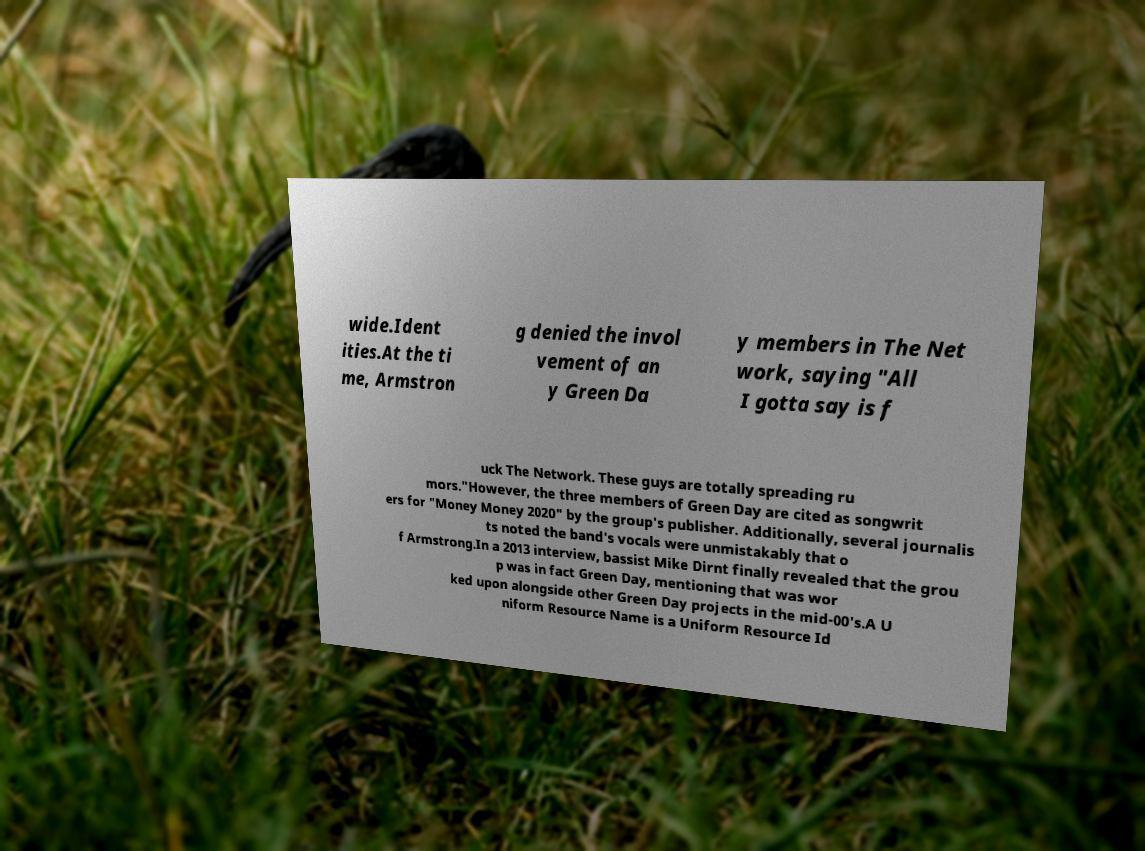Can you read and provide the text displayed in the image?This photo seems to have some interesting text. Can you extract and type it out for me? wide.Ident ities.At the ti me, Armstron g denied the invol vement of an y Green Da y members in The Net work, saying "All I gotta say is f uck The Network. These guys are totally spreading ru mors."However, the three members of Green Day are cited as songwrit ers for "Money Money 2020" by the group's publisher. Additionally, several journalis ts noted the band's vocals were unmistakably that o f Armstrong.In a 2013 interview, bassist Mike Dirnt finally revealed that the grou p was in fact Green Day, mentioning that was wor ked upon alongside other Green Day projects in the mid-00's.A U niform Resource Name is a Uniform Resource Id 